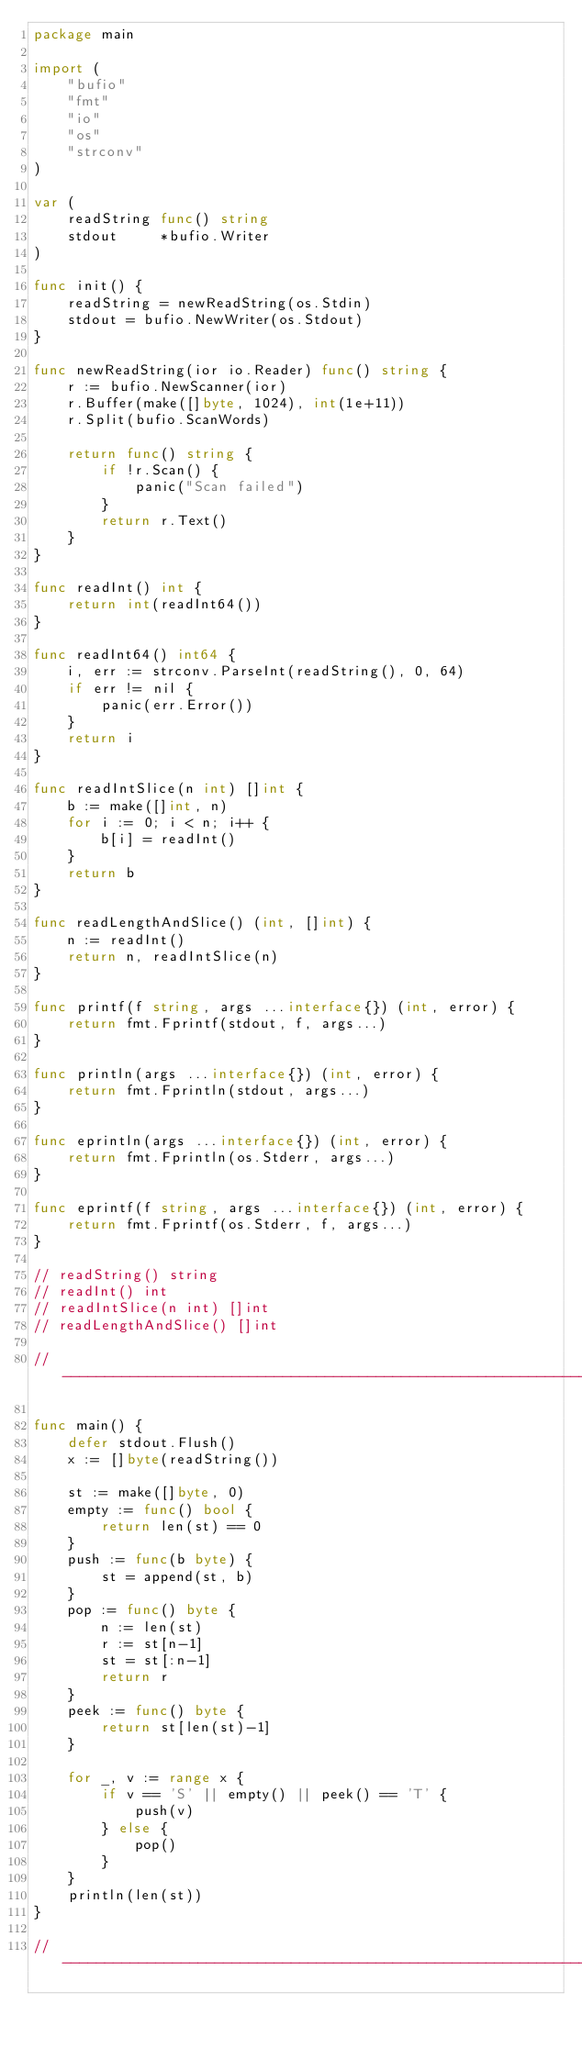Convert code to text. <code><loc_0><loc_0><loc_500><loc_500><_Go_>package main

import (
	"bufio"
	"fmt"
	"io"
	"os"
	"strconv"
)

var (
	readString func() string
	stdout     *bufio.Writer
)

func init() {
	readString = newReadString(os.Stdin)
	stdout = bufio.NewWriter(os.Stdout)
}

func newReadString(ior io.Reader) func() string {
	r := bufio.NewScanner(ior)
	r.Buffer(make([]byte, 1024), int(1e+11))
	r.Split(bufio.ScanWords)

	return func() string {
		if !r.Scan() {
			panic("Scan failed")
		}
		return r.Text()
	}
}

func readInt() int {
	return int(readInt64())
}

func readInt64() int64 {
	i, err := strconv.ParseInt(readString(), 0, 64)
	if err != nil {
		panic(err.Error())
	}
	return i
}

func readIntSlice(n int) []int {
	b := make([]int, n)
	for i := 0; i < n; i++ {
		b[i] = readInt()
	}
	return b
}

func readLengthAndSlice() (int, []int) {
	n := readInt()
	return n, readIntSlice(n)
}

func printf(f string, args ...interface{}) (int, error) {
	return fmt.Fprintf(stdout, f, args...)
}

func println(args ...interface{}) (int, error) {
	return fmt.Fprintln(stdout, args...)
}

func eprintln(args ...interface{}) (int, error) {
	return fmt.Fprintln(os.Stderr, args...)
}

func eprintf(f string, args ...interface{}) (int, error) {
	return fmt.Fprintf(os.Stderr, f, args...)
}

// readString() string
// readInt() int
// readIntSlice(n int) []int
// readLengthAndSlice() []int

// -----------------------------------------------------------------------------

func main() {
	defer stdout.Flush()
	x := []byte(readString())

	st := make([]byte, 0)
	empty := func() bool {
		return len(st) == 0
	}
	push := func(b byte) {
		st = append(st, b)
	}
	pop := func() byte {
		n := len(st)
		r := st[n-1]
		st = st[:n-1]
		return r
	}
	peek := func() byte {
		return st[len(st)-1]
	}

	for _, v := range x {
		if v == 'S' || empty() || peek() == 'T' {
			push(v)
		} else {
			pop()
		}
	}
	println(len(st))
}

// -----------------------------------------------------------------------------
</code> 